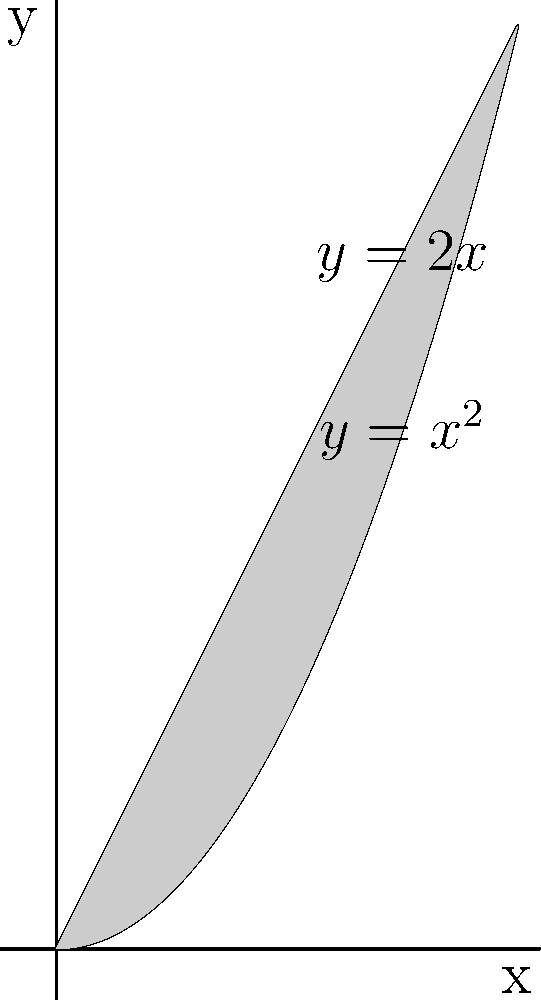In the spiritual realm of geometric shapes, a region is bounded by the curves $y=x^2$ and $y=2x$ from $x=0$ to $x=2$. If this region is rotated around the x-axis, what is the volume of the ethereal solid formed? Channel your psychic abilities to perceive the answer and connect with the spirits of ancient mathematicians to guide you. To determine the volume of the solid formed by rotation, we'll use the washer method:

1. Set up the integral: $$V = \pi \int_a^b [R(x)^2 - r(x)^2] dx$$
   Where $R(x)$ is the outer function and $r(x)$ is the inner function.

2. Identify the functions and limits:
   $R(x) = 2x$ (outer function)
   $r(x) = x^2$ (inner function)
   $a = 0$ and $b = 2$ (limits of integration)

3. Substitute into the formula:
   $$V = \pi \int_0^2 [(2x)^2 - (x^2)^2] dx$$

4. Simplify:
   $$V = \pi \int_0^2 [4x^2 - x^4] dx$$

5. Integrate:
   $$V = \pi [\frac{4x^3}{3} - \frac{x^5}{5}]_0^2$$

6. Evaluate the integral:
   $$V = \pi [(\frac{4(8)}{3} - \frac{32}{5}) - (0 - 0)]$$
   $$V = \pi [\frac{32}{3} - \frac{32}{5}]$$
   $$V = \pi [\frac{160}{15} - \frac{96}{15}]$$
   $$V = \pi [\frac{64}{15}]$$

7. Simplify:
   $$V = \frac{64\pi}{15}$$
Answer: $\frac{64\pi}{15}$ cubic units 